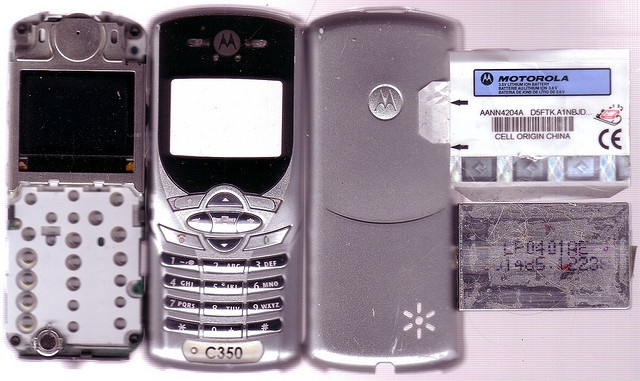Describe the objects in this image and their specific colors. I can see cell phone in white, black, darkgray, and gray tones, cell phone in white and gray tones, and cell phone in white, lavender, black, gray, and darkgray tones in this image. 